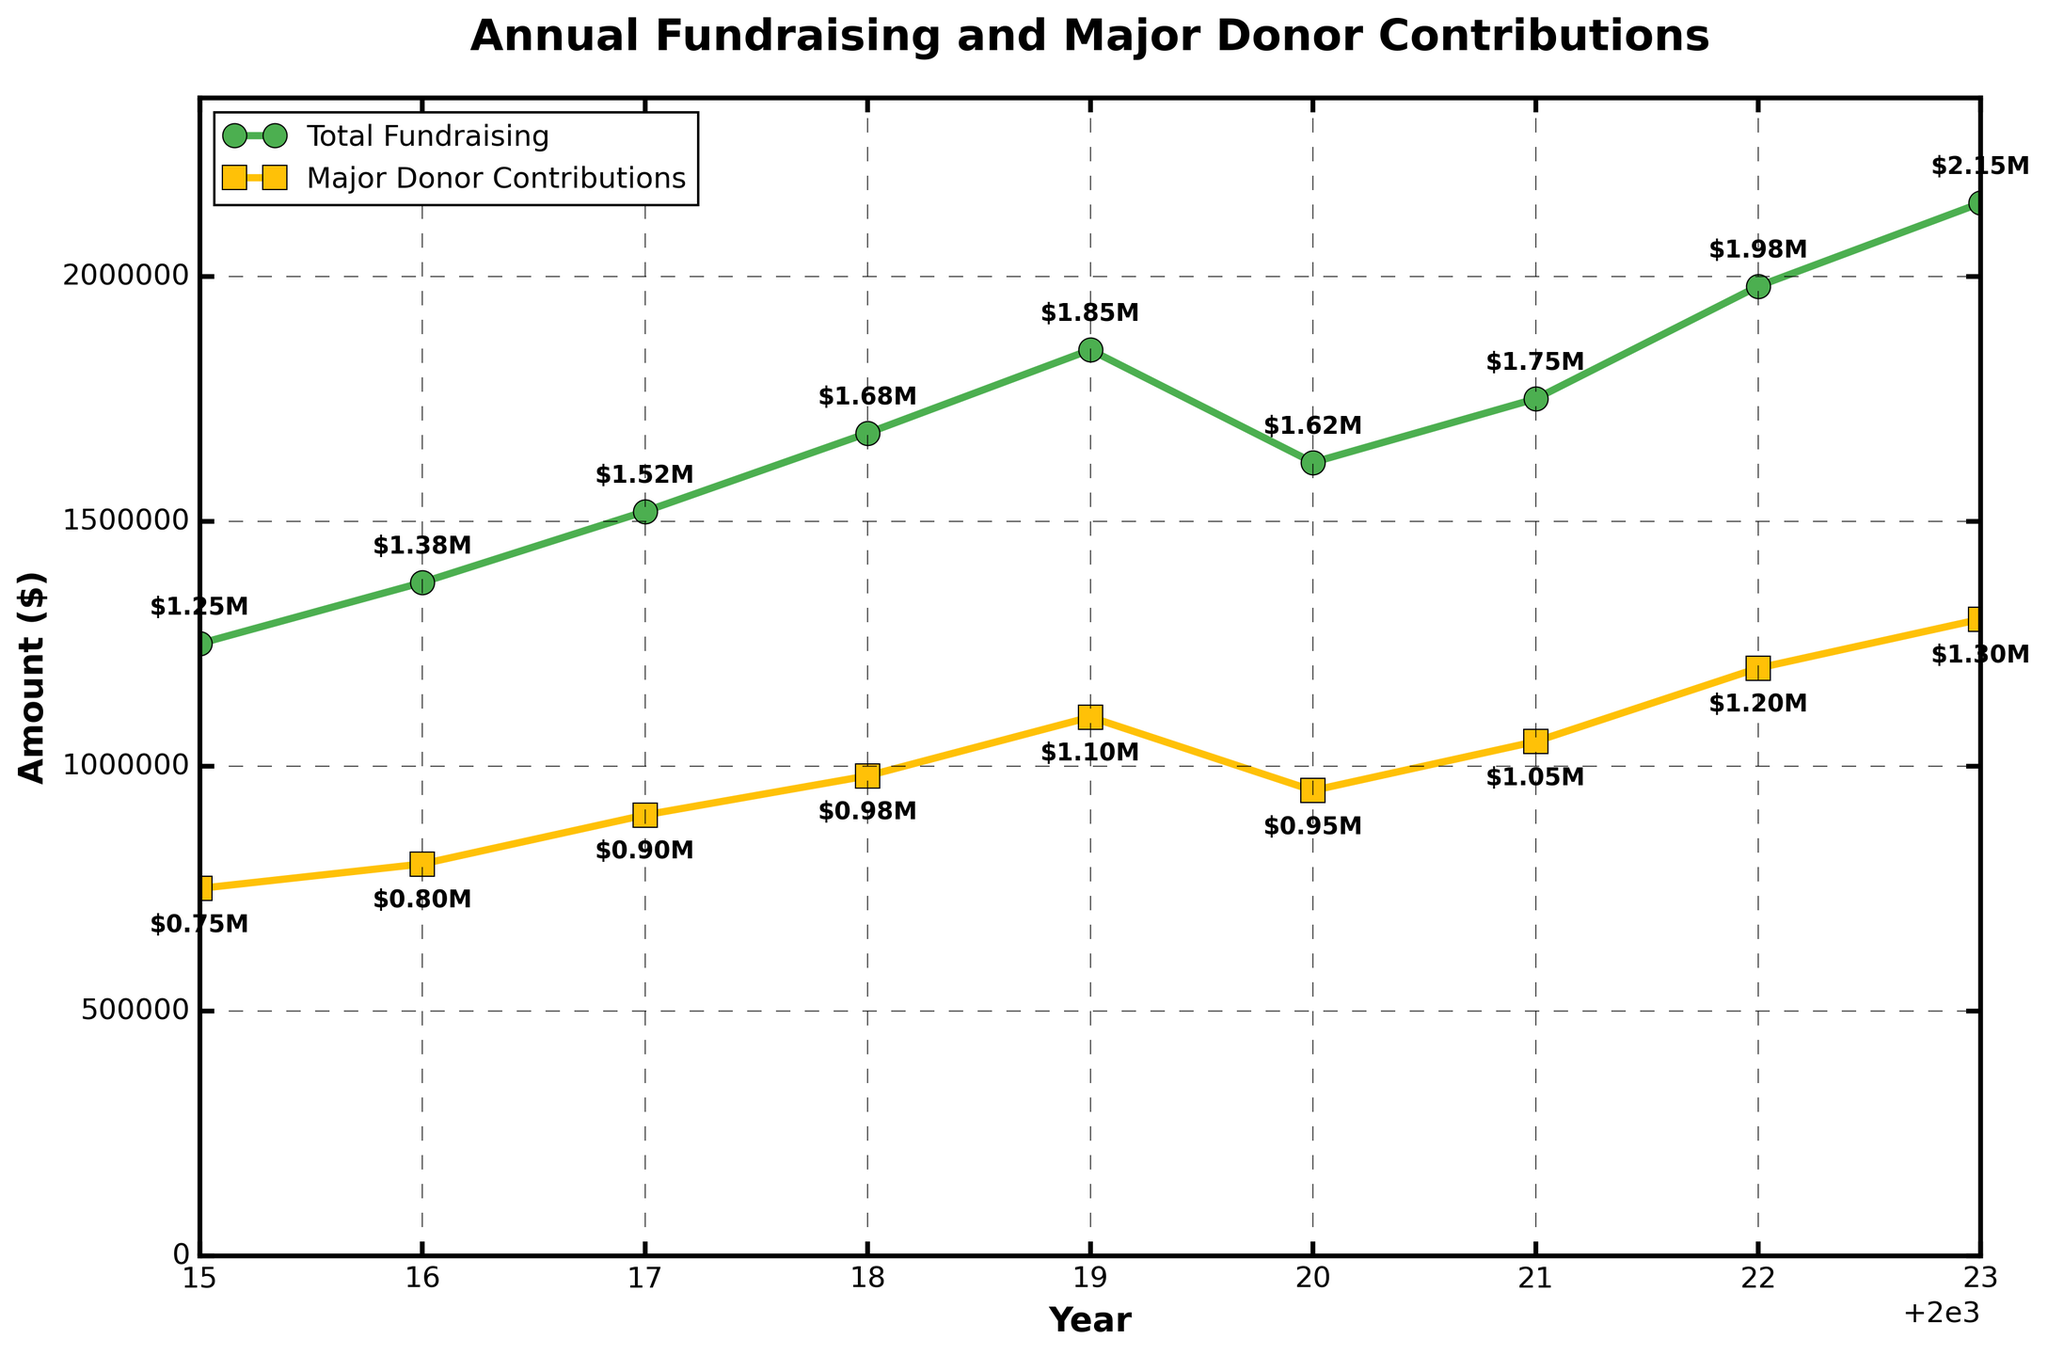What was the total fundraising amount in 2020? To find the total fundraising amount in 2020, look at the value on the line representing "Total Fundraising" at the year 2020.
Answer: $1,620,000 Which year saw the highest total fundraising? Identify the peak point on the "Total Fundraising" line. The highest point on that line corresponds to the year 2023.
Answer: 2023 What is the difference in major donor contributions between 2022 and 2023? Check the values on the "Major Donor Contributions" line for the years 2022 and 2023, then subtract the 2022 value from the 2023 value ($1,300,000 - $1,200,000).
Answer: $100,000 Which year had a decrease in total fundraising compared to the previous year? Examine the "Total Fundraising" line. Look for a downward trend from one year to the next. From 2019 to 2020, there is a decrease.
Answer: 2020 Did major donor contributions ever exceed total fundraising amounts? Compare the "Major Donor Contributions" line with the "Total Fundraising" line across all years. Both lines representing major donor contributions are always below the total fundraising line, meaning they never exceeded it.
Answer: No What is the average annual major donor contribution over the period from 2015 to 2023? Sum all annual major donor contributions and divide by the number of years: ($750,000 + $800,000 + $900,000 + $980,000 + $1,100,000 + $950,000 + $1,050,000 + $1,200,000 + $1,300,000) / 9
Answer: $1,003,333.33 How much did total fundraising grow from 2015 to 2019? Subtract the total fundraising amount in 2015 from the amount in 2019 ($1,850,000 - $1,250,000).
Answer: $600,000 What is the ratio of major donor contributions to total fundraising in 2017? Divide the value of major donor contributions in 2017 by the total fundraising amount in 2017: $900,000 / $1,520,000.
Answer: 0.592 (or 59.2%) Which line is green on the chart? By observing the chart, note the color of the lines. The "Total Fundraising" line is green in color.
Answer: Total Fundraising Between which consecutive years did total fundraising see the largest increase? Compare the differences between consecutive years on the "Total Fundraising" line. The largest increase is from 2022 to 2023 ($2,150,000 - $1,980,000 = $170,000).
Answer: 2022 and 2023 